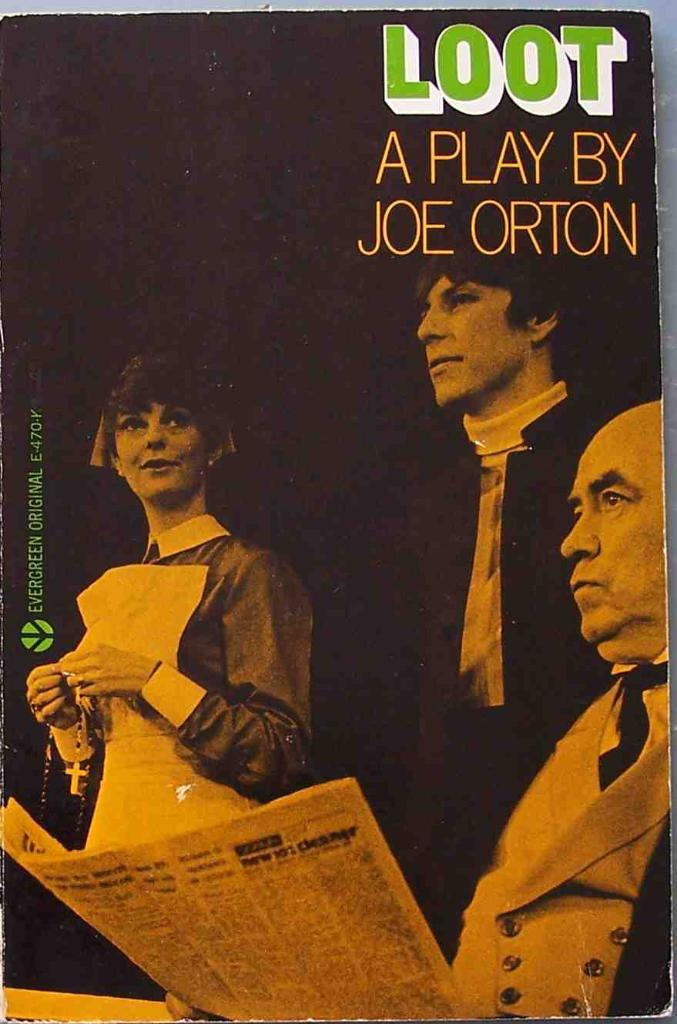<image>
Describe the image concisely. two men an a lady on a cover for loot a play by joe orton 